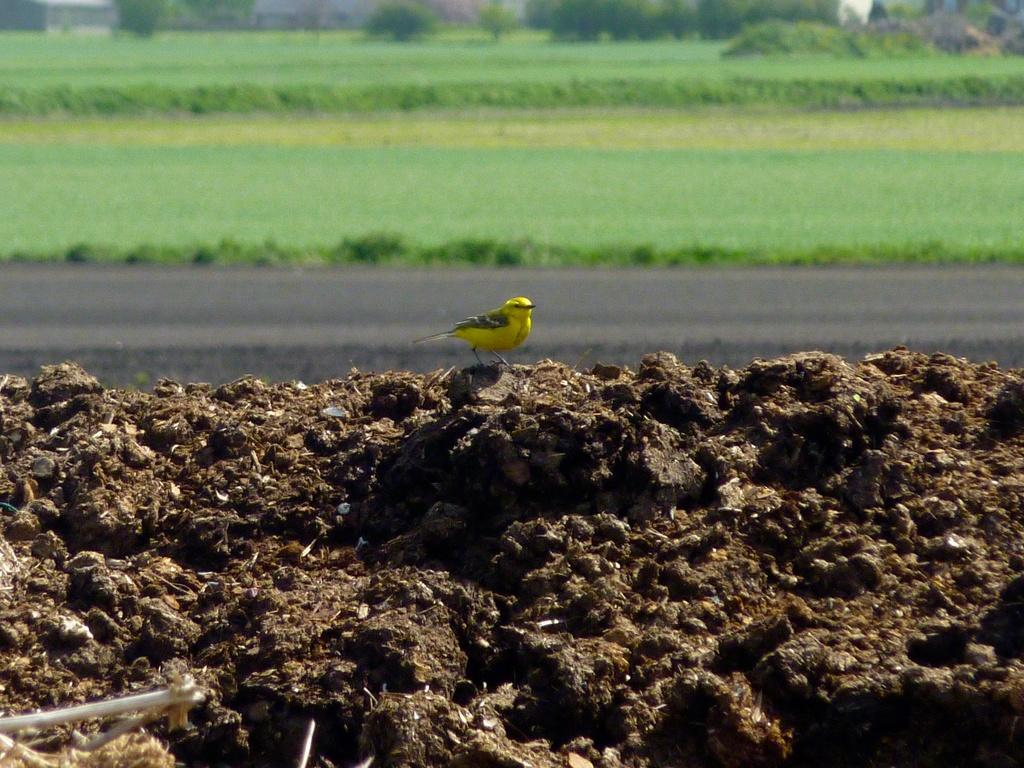What type of animal can be seen in the image? There is a bird in the image. What colors are present on the bird? The bird is yellow and black in color. Where is the bird located in the image? The bird is on the ground. What can be seen in the background of the image? There is grass and trees in the background of the image. How does the bird lift heavy objects in the image? The bird does not lift heavy objects in the image; it is simply perched on the ground. 